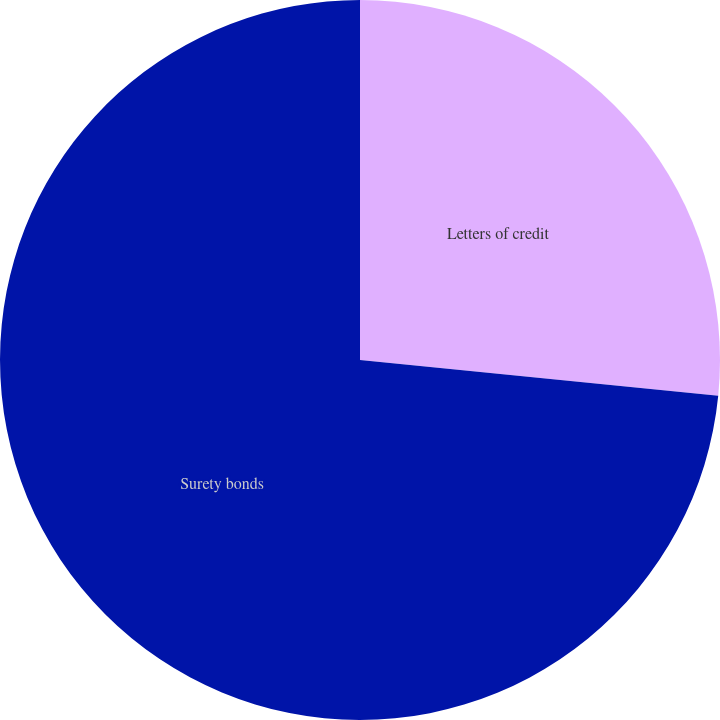Convert chart to OTSL. <chart><loc_0><loc_0><loc_500><loc_500><pie_chart><fcel>Letters of credit<fcel>Surety bonds<nl><fcel>26.58%<fcel>73.42%<nl></chart> 